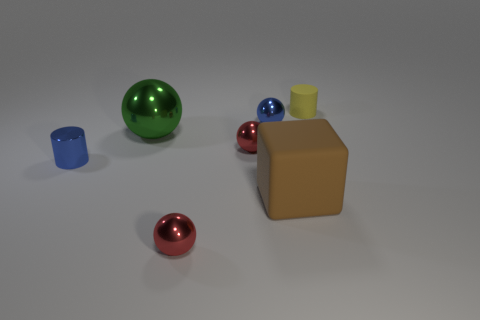Add 1 tiny brown matte balls. How many objects exist? 8 Subtract all cylinders. How many objects are left? 5 Add 2 tiny yellow things. How many tiny yellow things exist? 3 Subtract 0 purple blocks. How many objects are left? 7 Subtract all big green metallic objects. Subtract all blue metal spheres. How many objects are left? 5 Add 4 red metallic spheres. How many red metallic spheres are left? 6 